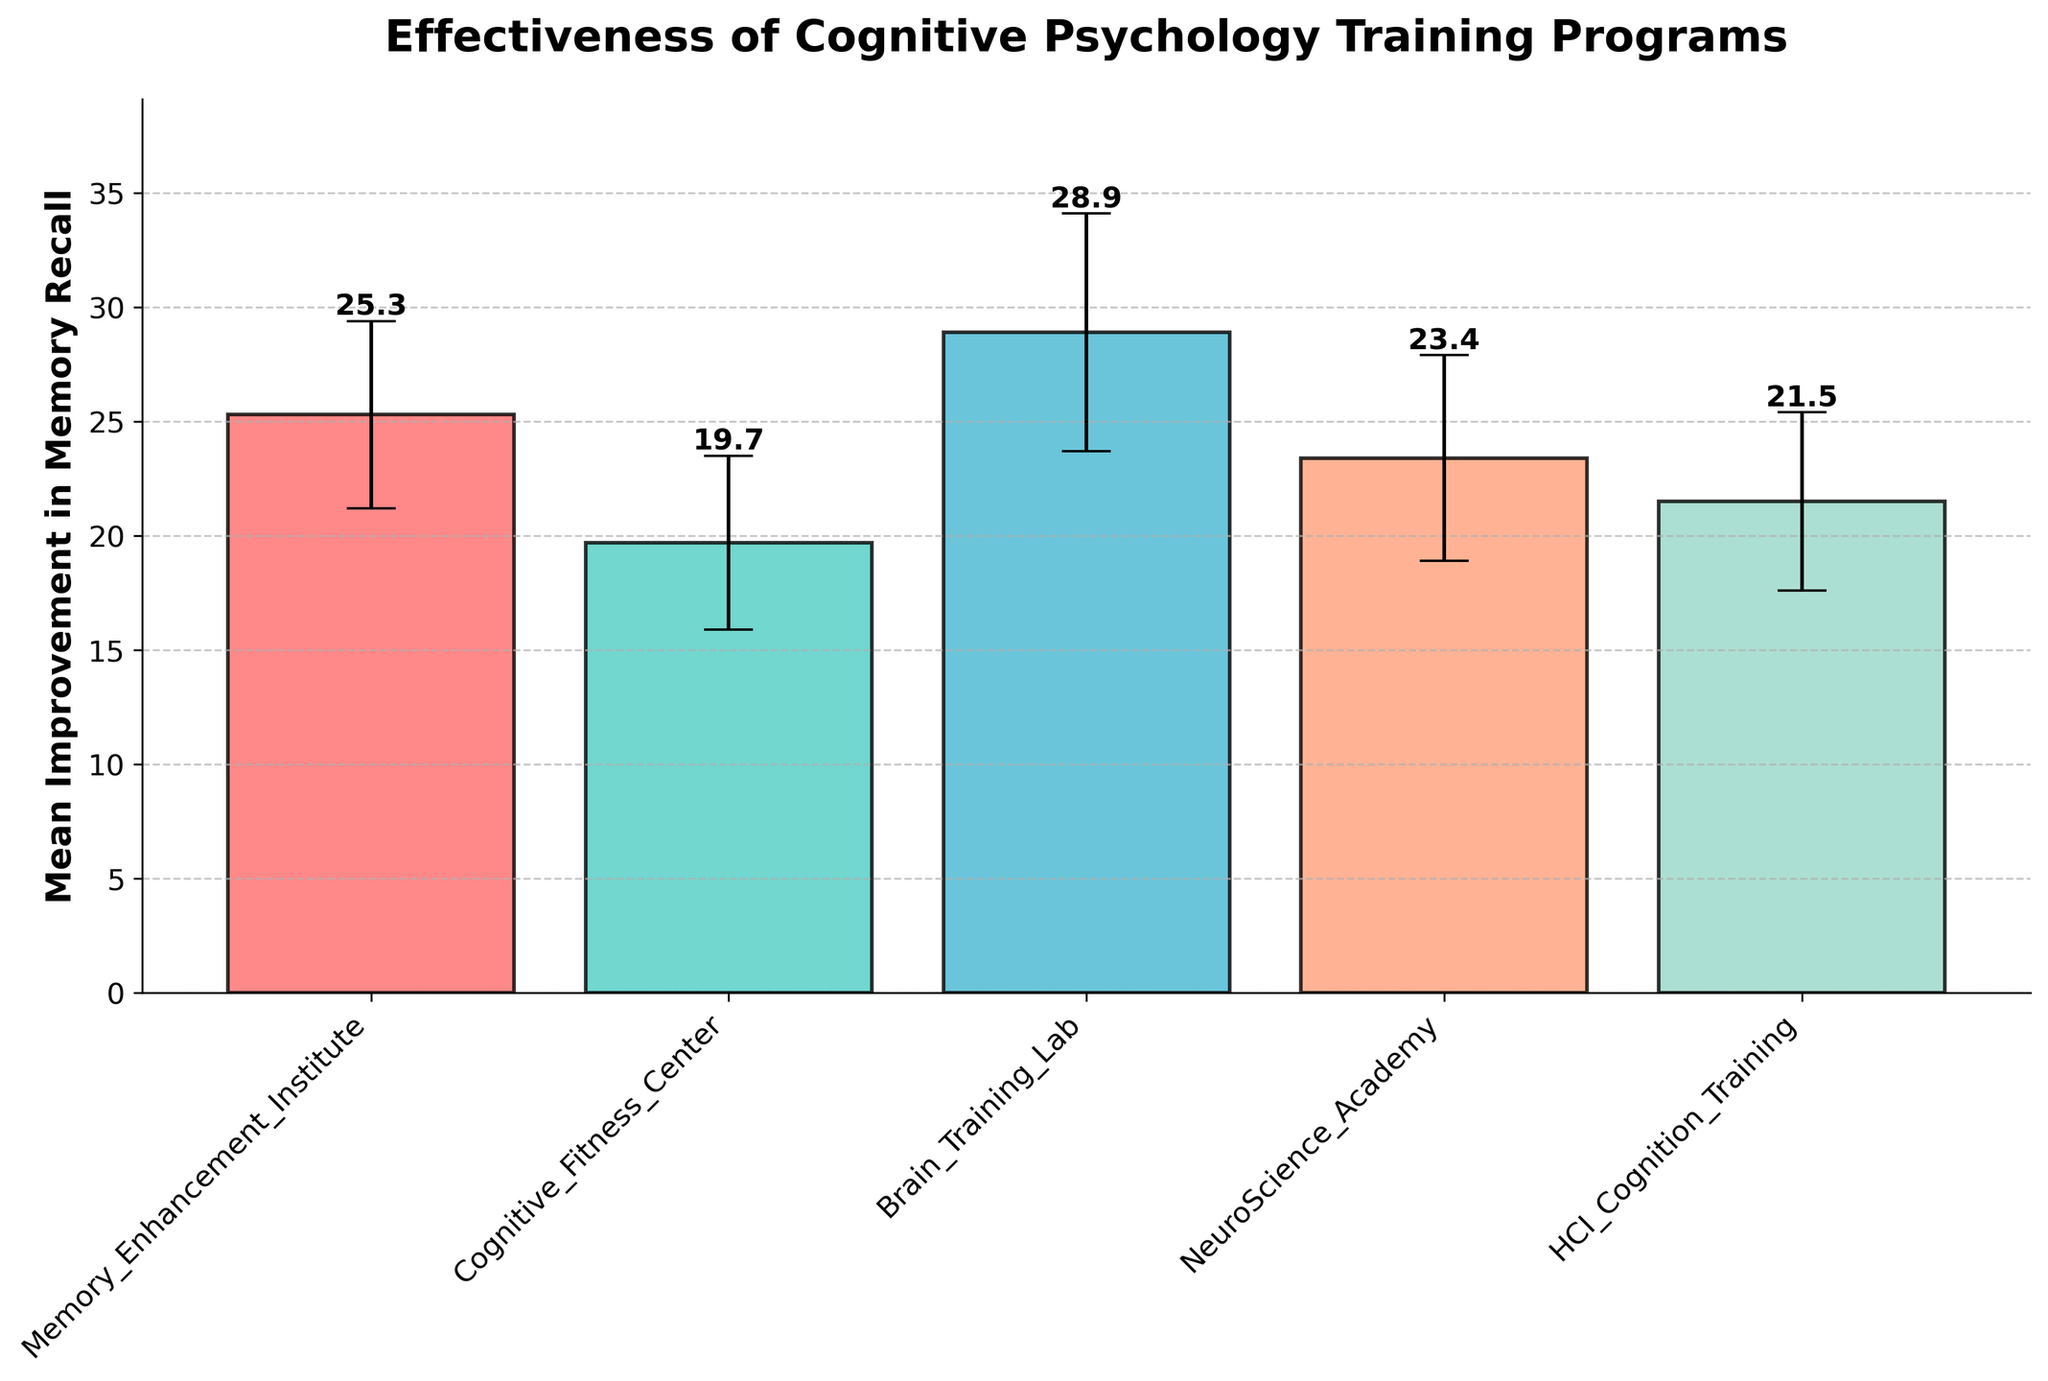What is the title of the figure? The title is typically located at the top of the figure and summarizes what the figure represents. Here, you can read the title directly from the plot.
Answer: Effectiveness of Cognitive Psychology Training Programs Which program has the highest mean improvement in memory recall? Look for the highest bar in the bar chart; the height of the bar represents the mean improvement. The text value on top of each bar can also be referenced.
Answer: Brain Training Lab What is the mean improvement of the NeuroScience Academy program? Find the bar labeled "NeuroScience Academy" and read the value at the top or along the y-axis.
Answer: 23.4 Which program has the smallest standard deviation in memory recall improvement? Look for the error bar (vertical line) with the smallest length. The shortest error bar indicates the smallest standard deviation.
Answer: Cognitive Fitness Center How much greater is the mean improvement of the Brain Training Lab compared to the Cognitive Fitness Center? Subtract the mean improvement of Cognitive Fitness Center from the mean improvement of Brain Training Lab (28.9 - 19.7).
Answer: 9.2 If you were to average the mean improvements of all the programs, what would it be? Add all the mean improvement values and divide by the number of programs: (25.3 + 19.7 + 28.9 + 23.4 + 21.5) / 5.
Answer: 23.76 Which program shows the most significant variability in training effectiveness? The program with the longest error bar (largest standard deviation) indicates the most variability.
Answer: Brain Training Lab What value is at the top right axis of the bar chart? This is determined by the highest value on the y-axis, which accounts for the maximum mean improvement plus the maximum error bar length.
Answer: 38 How do the mean improvements of HCI Cognition Training and Memory Enhancement Institute compare? Compare the heights of the bars for HCI Cognition Training and Memory Enhancement Institute or the values at the top of these bars. Memory Enhancement Institute has a higher mean improvement.
Answer: HCI Cognition Training < Memory Enhancement Institute What is the difference in standard deviation between Brain Training Lab and Memory Enhancement Institute? Subtract the standard deviation of Memory Enhancement Institute from Brain Training Lab (5.2 - 4.1).
Answer: 1.1 